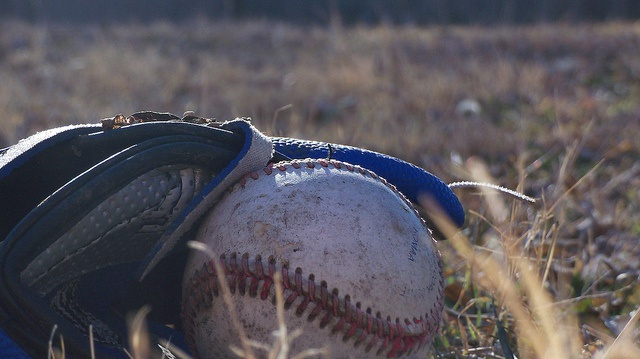Describe the objects in this image and their specific colors. I can see baseball glove in blue, black, navy, gray, and darkblue tones and sports ball in blue, gray, and black tones in this image. 